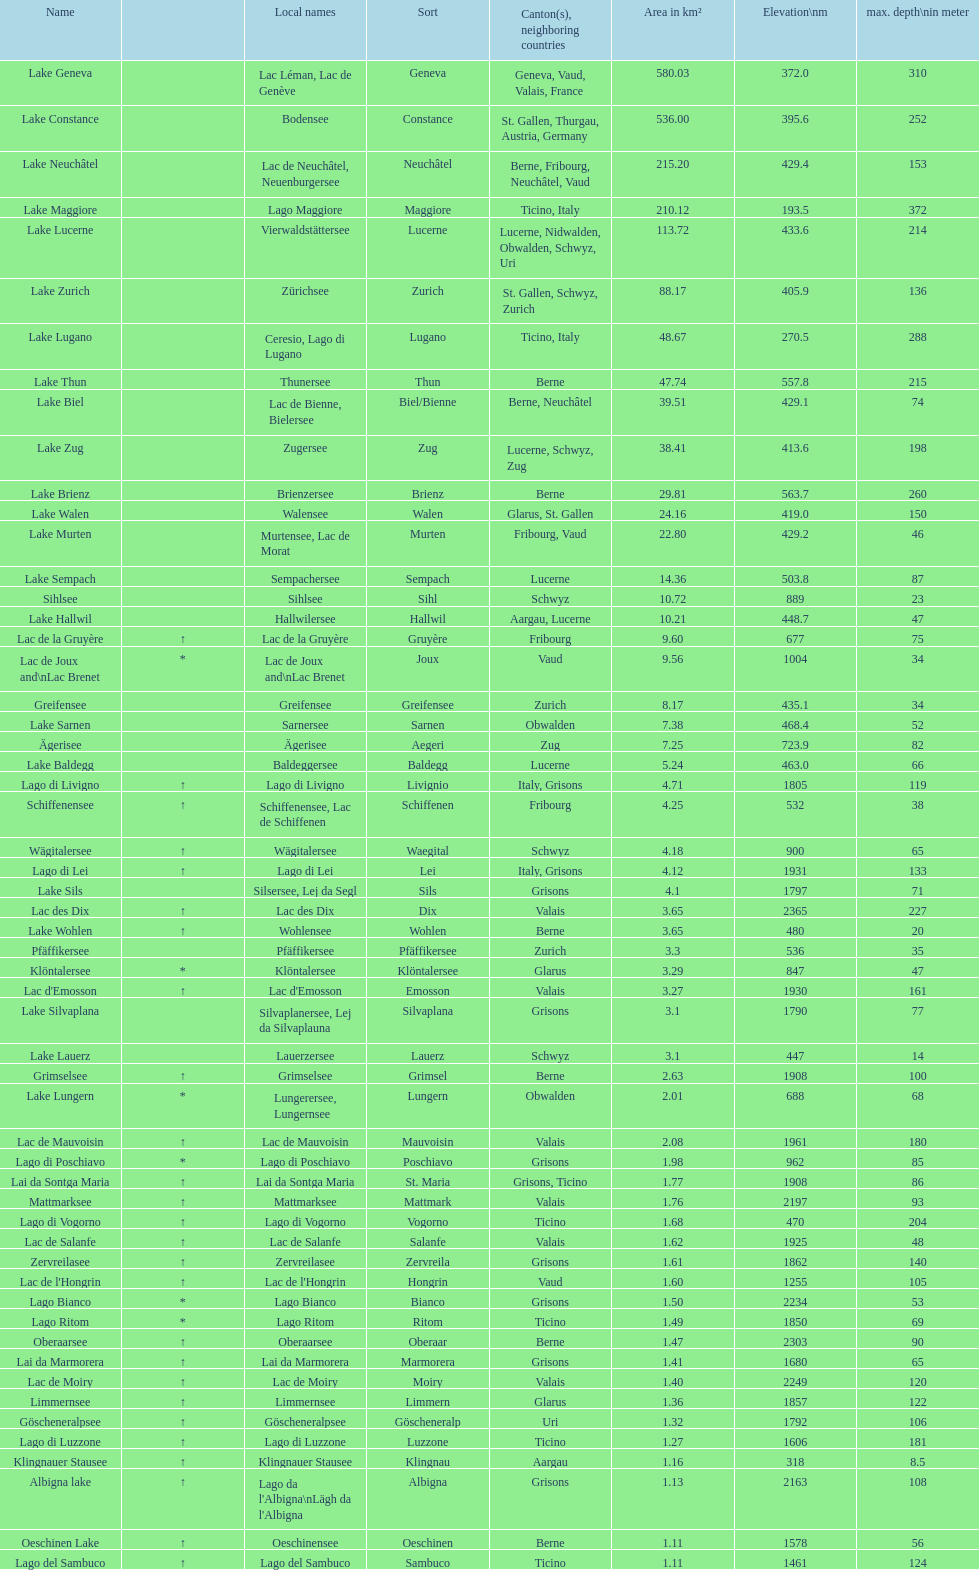What is the total area in km² of lake sils? 4.1. Would you be able to parse every entry in this table? {'header': ['Name', '', 'Local names', 'Sort', 'Canton(s), neighboring countries', 'Area in km²', 'Elevation\\nm', 'max. depth\\nin meter'], 'rows': [['Lake Geneva', '', 'Lac Léman, Lac de Genève', 'Geneva', 'Geneva, Vaud, Valais, France', '580.03', '372.0', '310'], ['Lake Constance', '', 'Bodensee', 'Constance', 'St. Gallen, Thurgau, Austria, Germany', '536.00', '395.6', '252'], ['Lake Neuchâtel', '', 'Lac de Neuchâtel, Neuenburgersee', 'Neuchâtel', 'Berne, Fribourg, Neuchâtel, Vaud', '215.20', '429.4', '153'], ['Lake Maggiore', '', 'Lago Maggiore', 'Maggiore', 'Ticino, Italy', '210.12', '193.5', '372'], ['Lake Lucerne', '', 'Vierwaldstättersee', 'Lucerne', 'Lucerne, Nidwalden, Obwalden, Schwyz, Uri', '113.72', '433.6', '214'], ['Lake Zurich', '', 'Zürichsee', 'Zurich', 'St. Gallen, Schwyz, Zurich', '88.17', '405.9', '136'], ['Lake Lugano', '', 'Ceresio, Lago di Lugano', 'Lugano', 'Ticino, Italy', '48.67', '270.5', '288'], ['Lake Thun', '', 'Thunersee', 'Thun', 'Berne', '47.74', '557.8', '215'], ['Lake Biel', '', 'Lac de Bienne, Bielersee', 'Biel/Bienne', 'Berne, Neuchâtel', '39.51', '429.1', '74'], ['Lake Zug', '', 'Zugersee', 'Zug', 'Lucerne, Schwyz, Zug', '38.41', '413.6', '198'], ['Lake Brienz', '', 'Brienzersee', 'Brienz', 'Berne', '29.81', '563.7', '260'], ['Lake Walen', '', 'Walensee', 'Walen', 'Glarus, St. Gallen', '24.16', '419.0', '150'], ['Lake Murten', '', 'Murtensee, Lac de Morat', 'Murten', 'Fribourg, Vaud', '22.80', '429.2', '46'], ['Lake Sempach', '', 'Sempachersee', 'Sempach', 'Lucerne', '14.36', '503.8', '87'], ['Sihlsee', '', 'Sihlsee', 'Sihl', 'Schwyz', '10.72', '889', '23'], ['Lake Hallwil', '', 'Hallwilersee', 'Hallwil', 'Aargau, Lucerne', '10.21', '448.7', '47'], ['Lac de la Gruyère', '↑', 'Lac de la Gruyère', 'Gruyère', 'Fribourg', '9.60', '677', '75'], ['Lac de Joux and\\nLac Brenet', '*', 'Lac de Joux and\\nLac Brenet', 'Joux', 'Vaud', '9.56', '1004', '34'], ['Greifensee', '', 'Greifensee', 'Greifensee', 'Zurich', '8.17', '435.1', '34'], ['Lake Sarnen', '', 'Sarnersee', 'Sarnen', 'Obwalden', '7.38', '468.4', '52'], ['Ägerisee', '', 'Ägerisee', 'Aegeri', 'Zug', '7.25', '723.9', '82'], ['Lake Baldegg', '', 'Baldeggersee', 'Baldegg', 'Lucerne', '5.24', '463.0', '66'], ['Lago di Livigno', '↑', 'Lago di Livigno', 'Livignio', 'Italy, Grisons', '4.71', '1805', '119'], ['Schiffenensee', '↑', 'Schiffenensee, Lac de Schiffenen', 'Schiffenen', 'Fribourg', '4.25', '532', '38'], ['Wägitalersee', '↑', 'Wägitalersee', 'Waegital', 'Schwyz', '4.18', '900', '65'], ['Lago di Lei', '↑', 'Lago di Lei', 'Lei', 'Italy, Grisons', '4.12', '1931', '133'], ['Lake Sils', '', 'Silsersee, Lej da Segl', 'Sils', 'Grisons', '4.1', '1797', '71'], ['Lac des Dix', '↑', 'Lac des Dix', 'Dix', 'Valais', '3.65', '2365', '227'], ['Lake Wohlen', '↑', 'Wohlensee', 'Wohlen', 'Berne', '3.65', '480', '20'], ['Pfäffikersee', '', 'Pfäffikersee', 'Pfäffikersee', 'Zurich', '3.3', '536', '35'], ['Klöntalersee', '*', 'Klöntalersee', 'Klöntalersee', 'Glarus', '3.29', '847', '47'], ["Lac d'Emosson", '↑', "Lac d'Emosson", 'Emosson', 'Valais', '3.27', '1930', '161'], ['Lake Silvaplana', '', 'Silvaplanersee, Lej da Silvaplauna', 'Silvaplana', 'Grisons', '3.1', '1790', '77'], ['Lake Lauerz', '', 'Lauerzersee', 'Lauerz', 'Schwyz', '3.1', '447', '14'], ['Grimselsee', '↑', 'Grimselsee', 'Grimsel', 'Berne', '2.63', '1908', '100'], ['Lake Lungern', '*', 'Lungerersee, Lungernsee', 'Lungern', 'Obwalden', '2.01', '688', '68'], ['Lac de Mauvoisin', '↑', 'Lac de Mauvoisin', 'Mauvoisin', 'Valais', '2.08', '1961', '180'], ['Lago di Poschiavo', '*', 'Lago di Poschiavo', 'Poschiavo', 'Grisons', '1.98', '962', '85'], ['Lai da Sontga Maria', '↑', 'Lai da Sontga Maria', 'St. Maria', 'Grisons, Ticino', '1.77', '1908', '86'], ['Mattmarksee', '↑', 'Mattmarksee', 'Mattmark', 'Valais', '1.76', '2197', '93'], ['Lago di Vogorno', '↑', 'Lago di Vogorno', 'Vogorno', 'Ticino', '1.68', '470', '204'], ['Lac de Salanfe', '↑', 'Lac de Salanfe', 'Salanfe', 'Valais', '1.62', '1925', '48'], ['Zervreilasee', '↑', 'Zervreilasee', 'Zervreila', 'Grisons', '1.61', '1862', '140'], ["Lac de l'Hongrin", '↑', "Lac de l'Hongrin", 'Hongrin', 'Vaud', '1.60', '1255', '105'], ['Lago Bianco', '*', 'Lago Bianco', 'Bianco', 'Grisons', '1.50', '2234', '53'], ['Lago Ritom', '*', 'Lago Ritom', 'Ritom', 'Ticino', '1.49', '1850', '69'], ['Oberaarsee', '↑', 'Oberaarsee', 'Oberaar', 'Berne', '1.47', '2303', '90'], ['Lai da Marmorera', '↑', 'Lai da Marmorera', 'Marmorera', 'Grisons', '1.41', '1680', '65'], ['Lac de Moiry', '↑', 'Lac de Moiry', 'Moiry', 'Valais', '1.40', '2249', '120'], ['Limmernsee', '↑', 'Limmernsee', 'Limmern', 'Glarus', '1.36', '1857', '122'], ['Göscheneralpsee', '↑', 'Göscheneralpsee', 'Göscheneralp', 'Uri', '1.32', '1792', '106'], ['Lago di Luzzone', '↑', 'Lago di Luzzone', 'Luzzone', 'Ticino', '1.27', '1606', '181'], ['Klingnauer Stausee', '↑', 'Klingnauer Stausee', 'Klingnau', 'Aargau', '1.16', '318', '8.5'], ['Albigna lake', '↑', "Lago da l'Albigna\\nLägh da l'Albigna", 'Albigna', 'Grisons', '1.13', '2163', '108'], ['Oeschinen Lake', '↑', 'Oeschinensee', 'Oeschinen', 'Berne', '1.11', '1578', '56'], ['Lago del Sambuco', '↑', 'Lago del Sambuco', 'Sambuco', 'Ticino', '1.11', '1461', '124']]} 